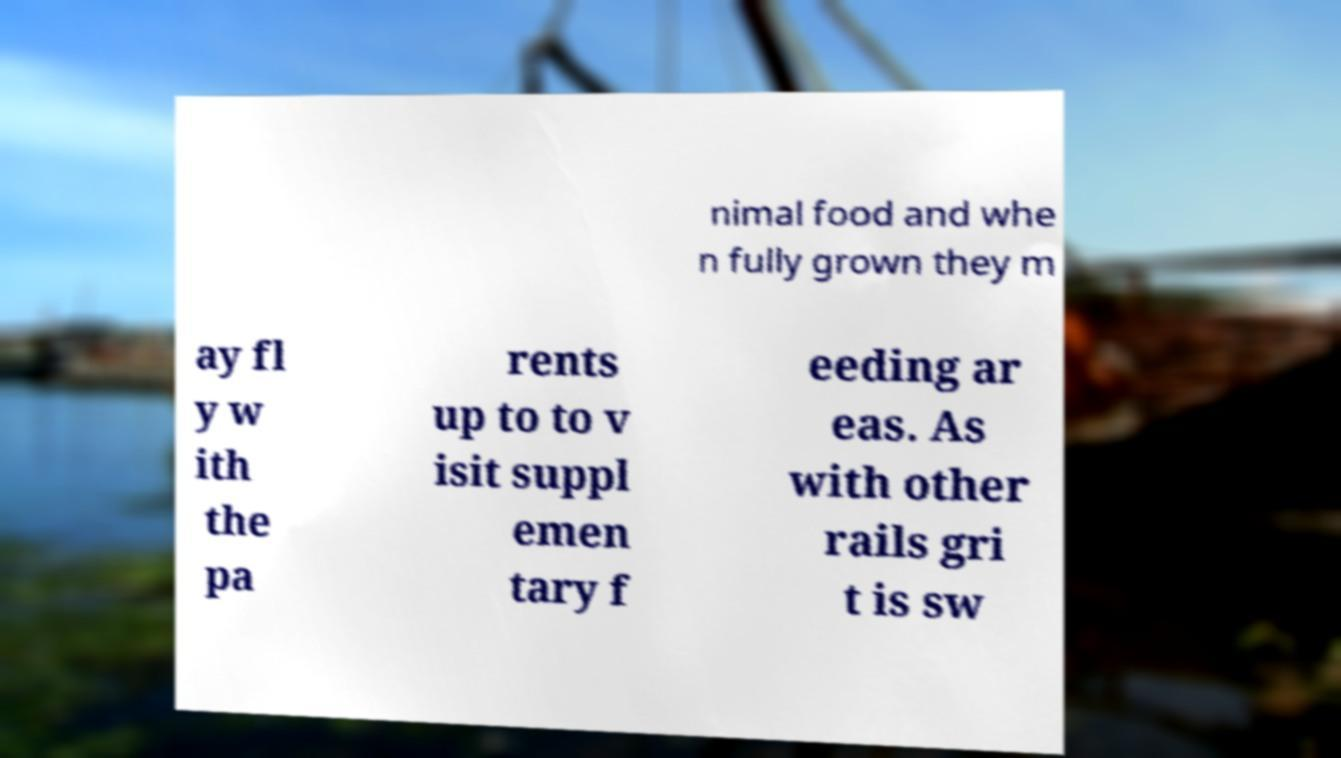Please identify and transcribe the text found in this image. nimal food and whe n fully grown they m ay fl y w ith the pa rents up to to v isit suppl emen tary f eeding ar eas. As with other rails gri t is sw 